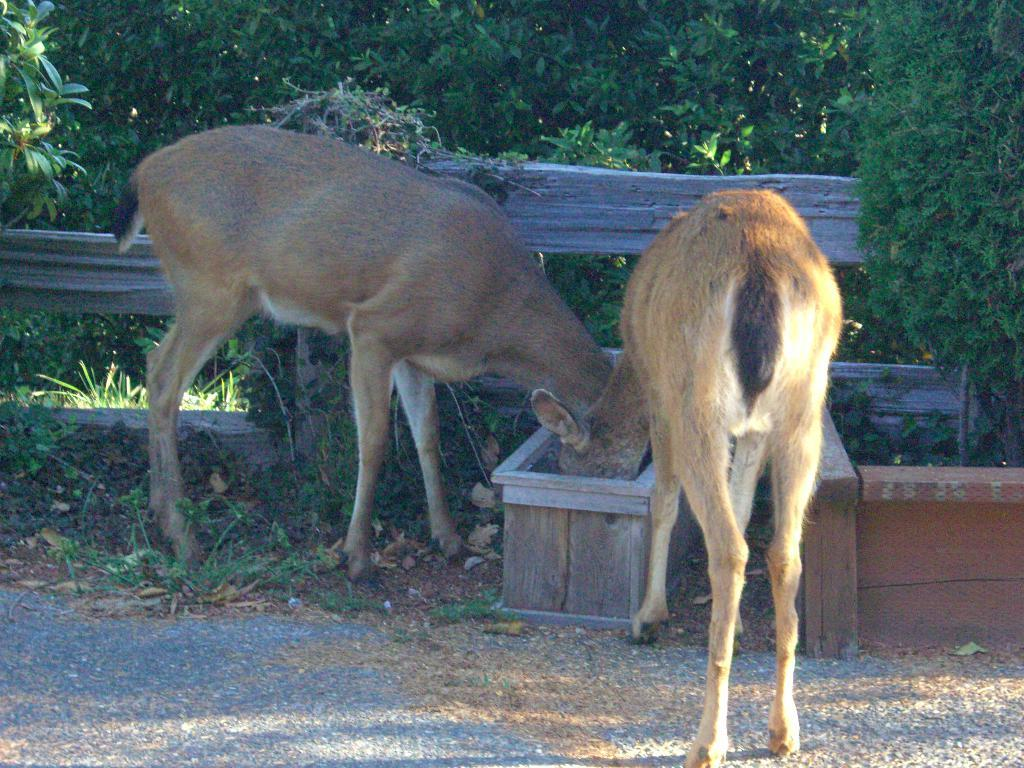What is present in the image in terms of living creatures? There are two animals in the image. What are the animals doing in the image? The animals are eating something from a box. What can be seen in the background of the image? There is a wooden fencing and trees in the background of the image. What type of wood is the drawer made of in the image? There is no drawer present in the image. 